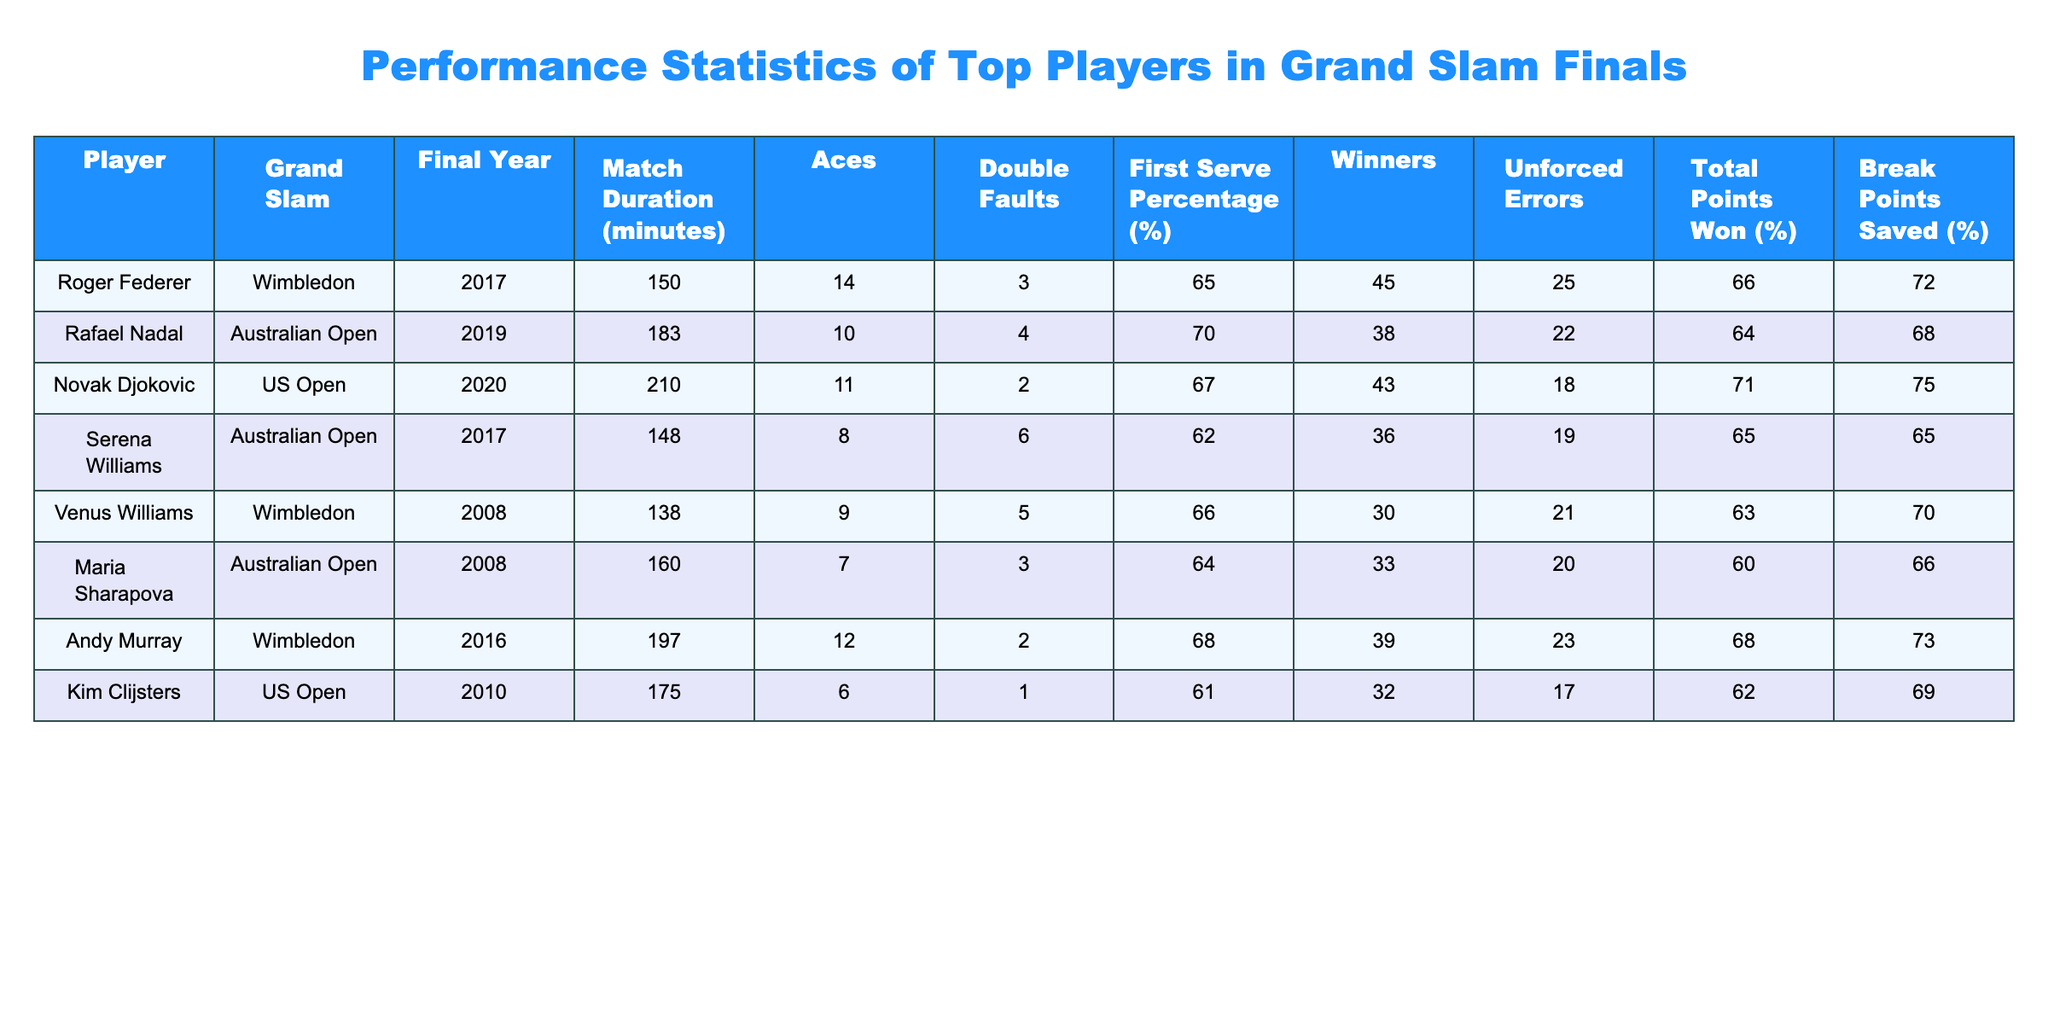What is the match duration for Novak Djokovic's US Open final in 2020? The match duration is listed in the table under the "Match Duration (minutes)" column for Novak Djokovic, specifically for the year 2020 at the US Open. It reads 210 minutes.
Answer: 210 minutes Which player had the highest number of aces in the finals recorded? By examining the "Aces" column, we find that Roger Federer had the highest number of aces at 14 during the Wimbledon final in 2017.
Answer: Roger Federer with 14 aces How many total break points did Kim Clijsters save in her 2010 US Open final? In the table, we can find Kim Clijsters listed under the US Open for 2010, with the "Break Points Saved (%)" indicating that she saved 69% of her break points.
Answer: 69% What is the difference in first serve percentage between Rafael Nadal and Venus Williams in their respective finals? To find the difference, we look at the "First Serve Percentage (%)" column: Nadal had 70% and Venus had 66%. The difference is 70% - 66% = 4%.
Answer: 4% Which player had fewer double faults in their final, Andy Murray or Serena Williams? When comparing the "Double Faults" column, Andy Murray had 2 double faults while Serena Williams had 6. Since 2 is less than 6, Andy Murray had fewer double faults.
Answer: Andy Murray had fewer double faults What is the average match duration of the finals played by the listed players? To find the average, we first sum the match durations: 150 + 183 + 210 + 148 + 138 + 160 + 197 + 175 = 1261. Then, we divide by the total number of finals (8), resulting in an average match duration of 1261/8 = 157.625 minutes.
Answer: 157.625 minutes Did Maria Sharapova have a higher percentage of total points won than Kim Clijsters in the finals? Looking at the "Total Points Won (%)" column, Maria Sharapova won 60% of her points, while Kim Clijsters won 62%. Since 60% is less than 62%, the answer is no.
Answer: No Which player achieved the lowest total points won percentage in their final? By checking the "Total Points Won (%)" column, we see that Maria Sharapova recorded the lowest percentage at 60%.
Answer: Maria Sharapova with 60% 